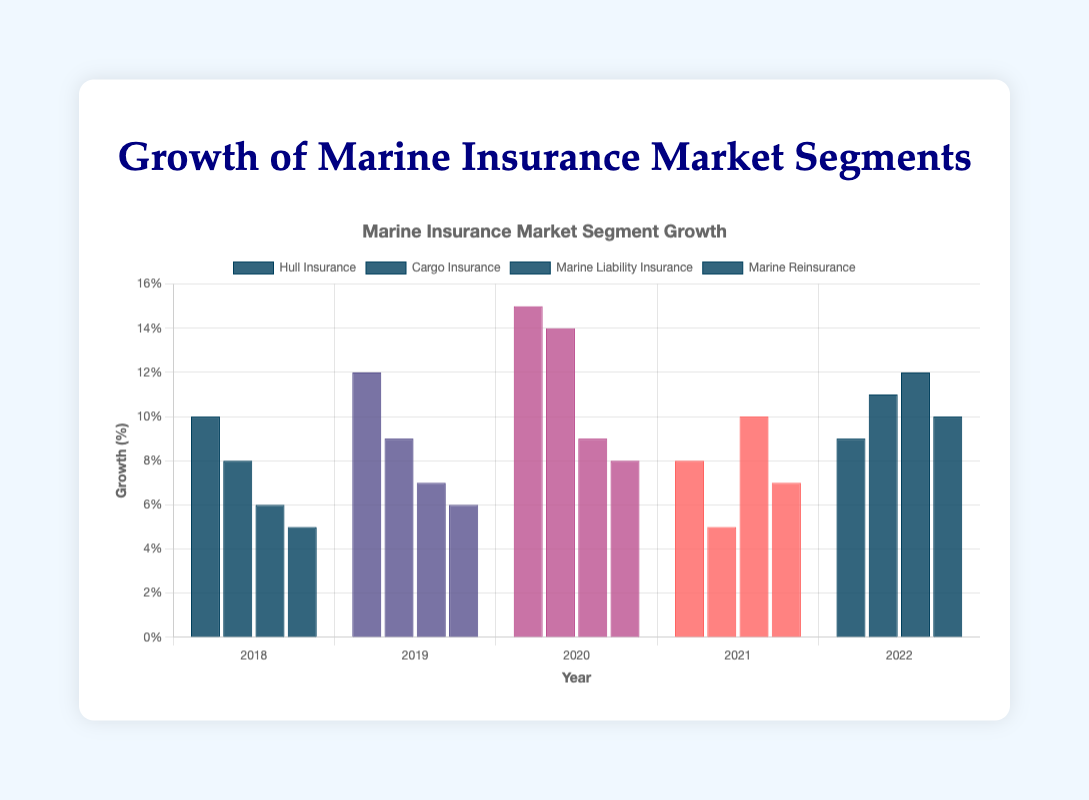Which segment showed the highest growth in 2022? Compare the growth values in 2022 for all segments. Hull Insurance: 9%, Cargo Insurance: 11%, Marine Liability Insurance: 12%, Marine Reinsurance: 10%. Marine Liability Insurance has the highest growth at 12%.
Answer: Marine Liability Insurance Which year did Hull Insurance experience the highest growth? Look at the growth values for Hull Insurance each year: 2018: 10%, 2019: 12%, 2020: 15%, 2021: 8%, 2022: 9%. The highest growth is in 2020 at 15%.
Answer: 2020 By how much did Cargo Insurance's growth decrease from 2020 to 2021? Subtract the growth in 2021 from the growth in 2020 for Cargo Insurance: 2020: 14%, 2021: 5%. The decrease is 14% - 5% = 9%.
Answer: 9% What is the average growth of Marine Reinsurance over the five years? Calculate the average by summing the values and dividing by the number of years: (5% + 6% + 8% + 7% + 10%) / 5 = 36% / 5 = 7.2%.
Answer: 7.2% Which segment had the least growth in 2019? Compare the 2019 growth values: Hull Insurance: 12%, Cargo Insurance: 9%, Marine Liability Insurance: 7%, Marine Reinsurance: 6%. Marine Reinsurance had the least growth at 6%.
Answer: Marine Reinsurance What's the total growth of Hull Insurance over the five years? Sum up the growth values for Hull Insurance: 10% + 12% + 15% + 8% + 9% = 54%.
Answer: 54% Is the growth of Marine Liability Insurance in 2021 greater than the growth of Cargo Insurance in 2022? Compare the growth values: Marine Liability Insurance in 2021: 10%, Cargo Insurance in 2022: 11%. Cargo Insurance in 2022 is greater.
Answer: No For how many years did Marine Reinsurance have growth below 7%? Check each year's growth: 2018: 5%, 2019: 6%, 2020: 8%, 2021: 7%, 2022: 10%. The years with growth below 7% are 2018 and 2019. So, there are 2 years.
Answer: 2 